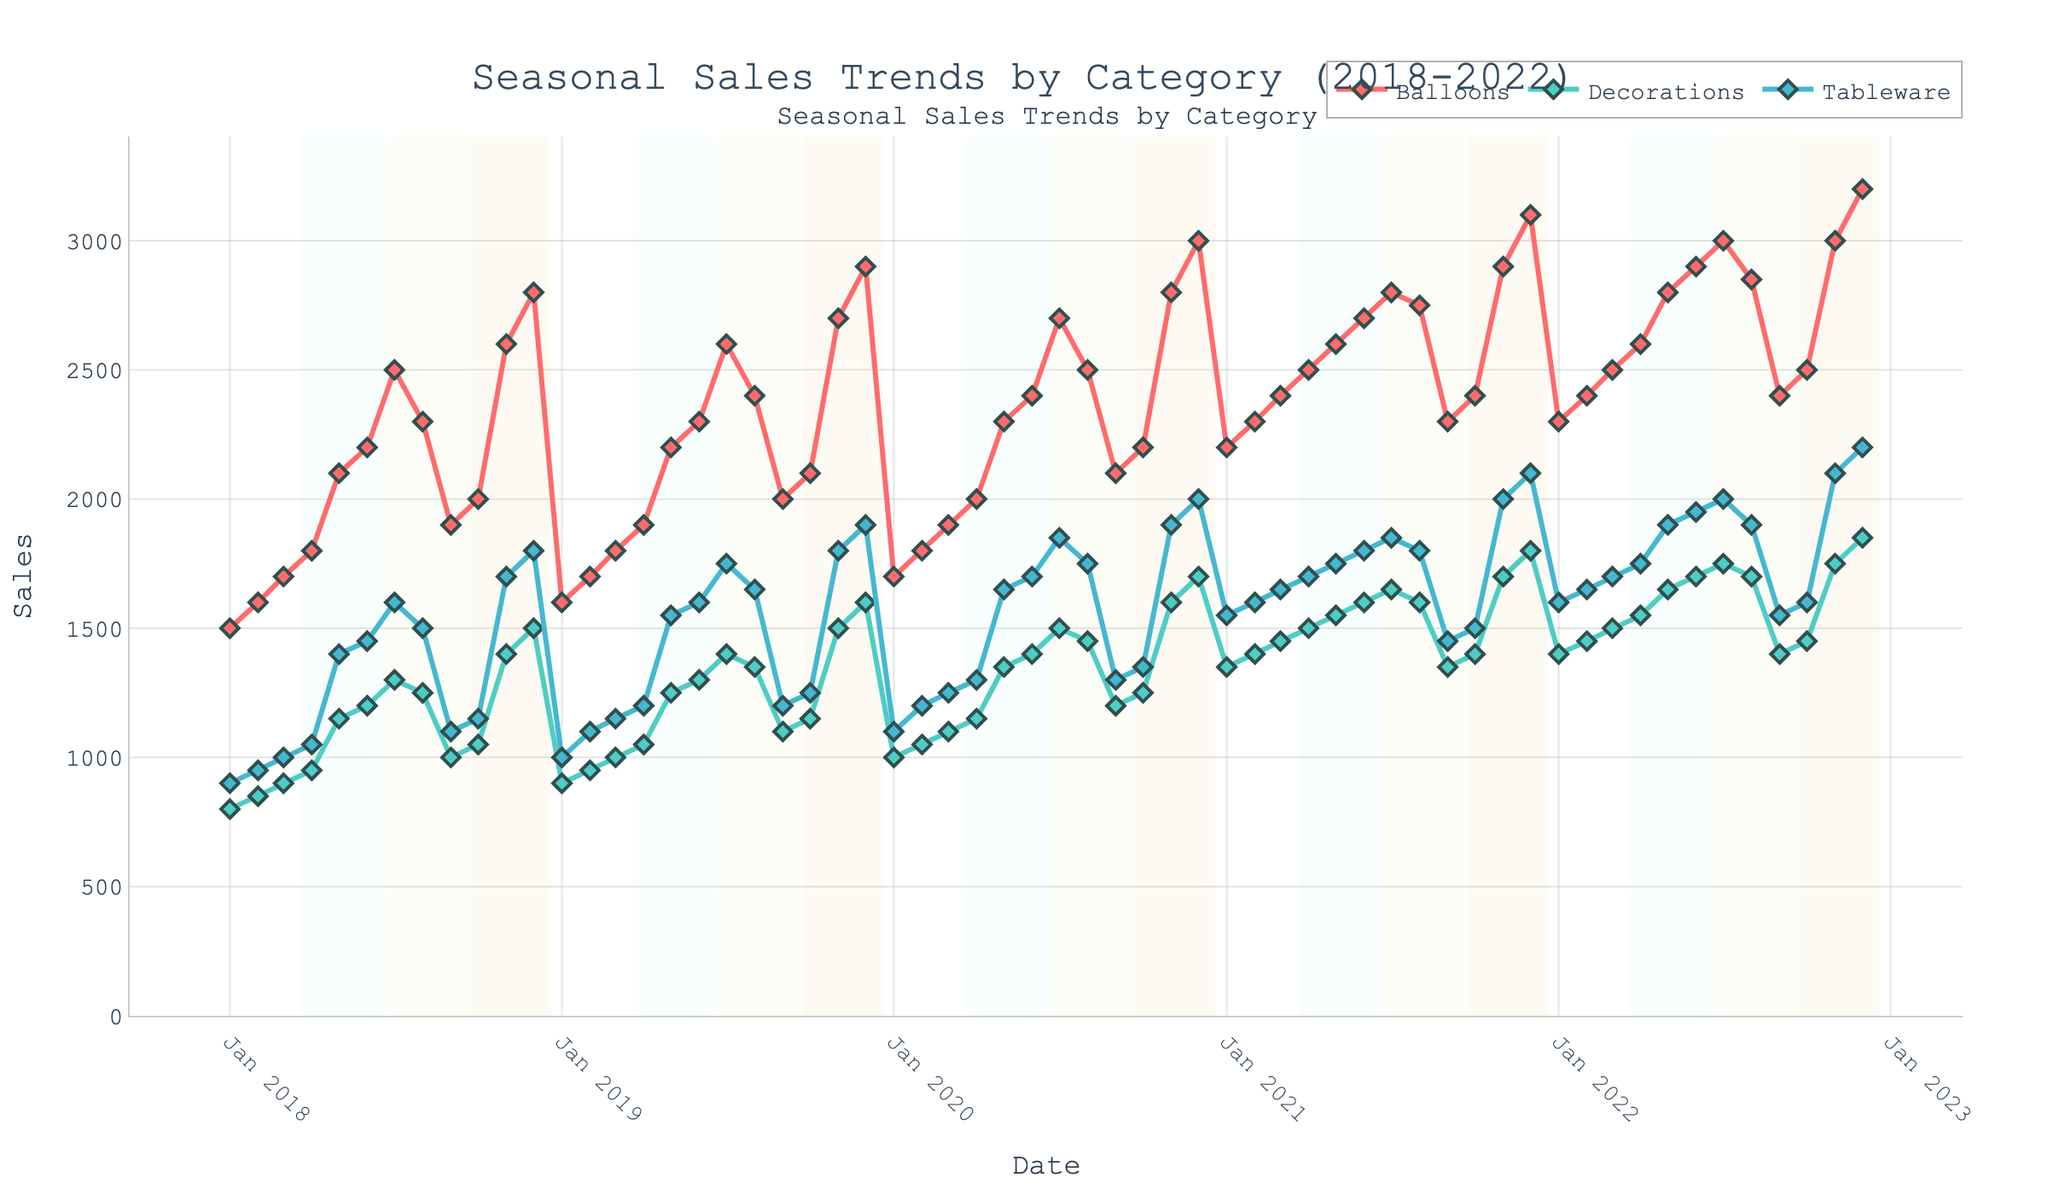What is the title of the figure? The title is typically placed prominently at the top of the figure. In this case, it is labeled "Seasonal Sales Trends by Category (2018-2022)".
Answer: Seasonal Sales Trends by Category (2018-2022) What color is used to represent the 'Balloons' category? Each category is represented by a distinct color. The 'Balloons' category is depicted in a shade of red.
Answer: Red Which month and year saw the highest sales for 'Tableware'? The highest point on the 'Tableware' line is observable by visually tracking the peaks. The peak occurs in December 2022.
Answer: December 2022 Which category experienced the steepest increase in sales between May and July of any year? By examining the slopes of the lines from May to July across different years, we observe that 'Balloons' consistently shows the steepest upward trend between these months.
Answer: Balloons What is the average sales for 'Decorations' in the year 2020? The sales values for 'Decorations' in 2020 are totaled (1000+1050+1100+1150+1350+1400+1500+1450+1200+1250+1600+1700) and then divided by 12 (the number of months) to find the average: (15750 / 12) = 1312.5.
Answer: 1312.5 Which season generally sees the highest sales for 'Balloons'? Seasonal trends are highlighted with color blocks in the background. The 'Balloons' category consistently peaks during the Winter and Summer months, but Winter has slightly higher peaks.
Answer: Winter How do 'Tableware' sales in July 2020 compare to those in July 2021? Comparing the points for July in both years, the sales in July 2020 were 1850, whereas in July 2021 they were also 1850. Thus, they are equal.
Answer: Equal What trend is observed in 'Decorations' sales during the Fall of each year? The figure highlights Fall seasons in a specific color, allowing for easy observation of trends. Generally, there is an upward trend in 'Decorations' sales during the Fall, particularly peaking towards November.
Answer: Upward trend How much did sales for 'Balloons' increase from January 2022 to December 2022? Sales in January 2022 were 2300, and they increased to 3200 by December 2022. The increase is calculated as 3200 - 2300 = 900.
Answer: 900 Do all categories have their lowest sales in the same month? By tracking the lowest points on each line, we see that while 'Tableware' and 'Decorations' generally have their lowest sales in January, 'Balloons' have their low points scattered, with notable lows in September of several years.
Answer: No 